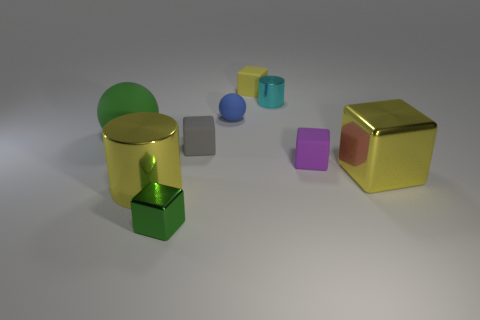Subtract all gray cubes. How many cubes are left? 4 Subtract all gray cubes. How many cubes are left? 4 Subtract all red cubes. Subtract all blue spheres. How many cubes are left? 5 Subtract all cylinders. How many objects are left? 7 Add 5 small green blocks. How many small green blocks are left? 6 Add 3 blue cubes. How many blue cubes exist? 3 Subtract 0 gray cylinders. How many objects are left? 9 Subtract all small purple matte blocks. Subtract all tiny cylinders. How many objects are left? 7 